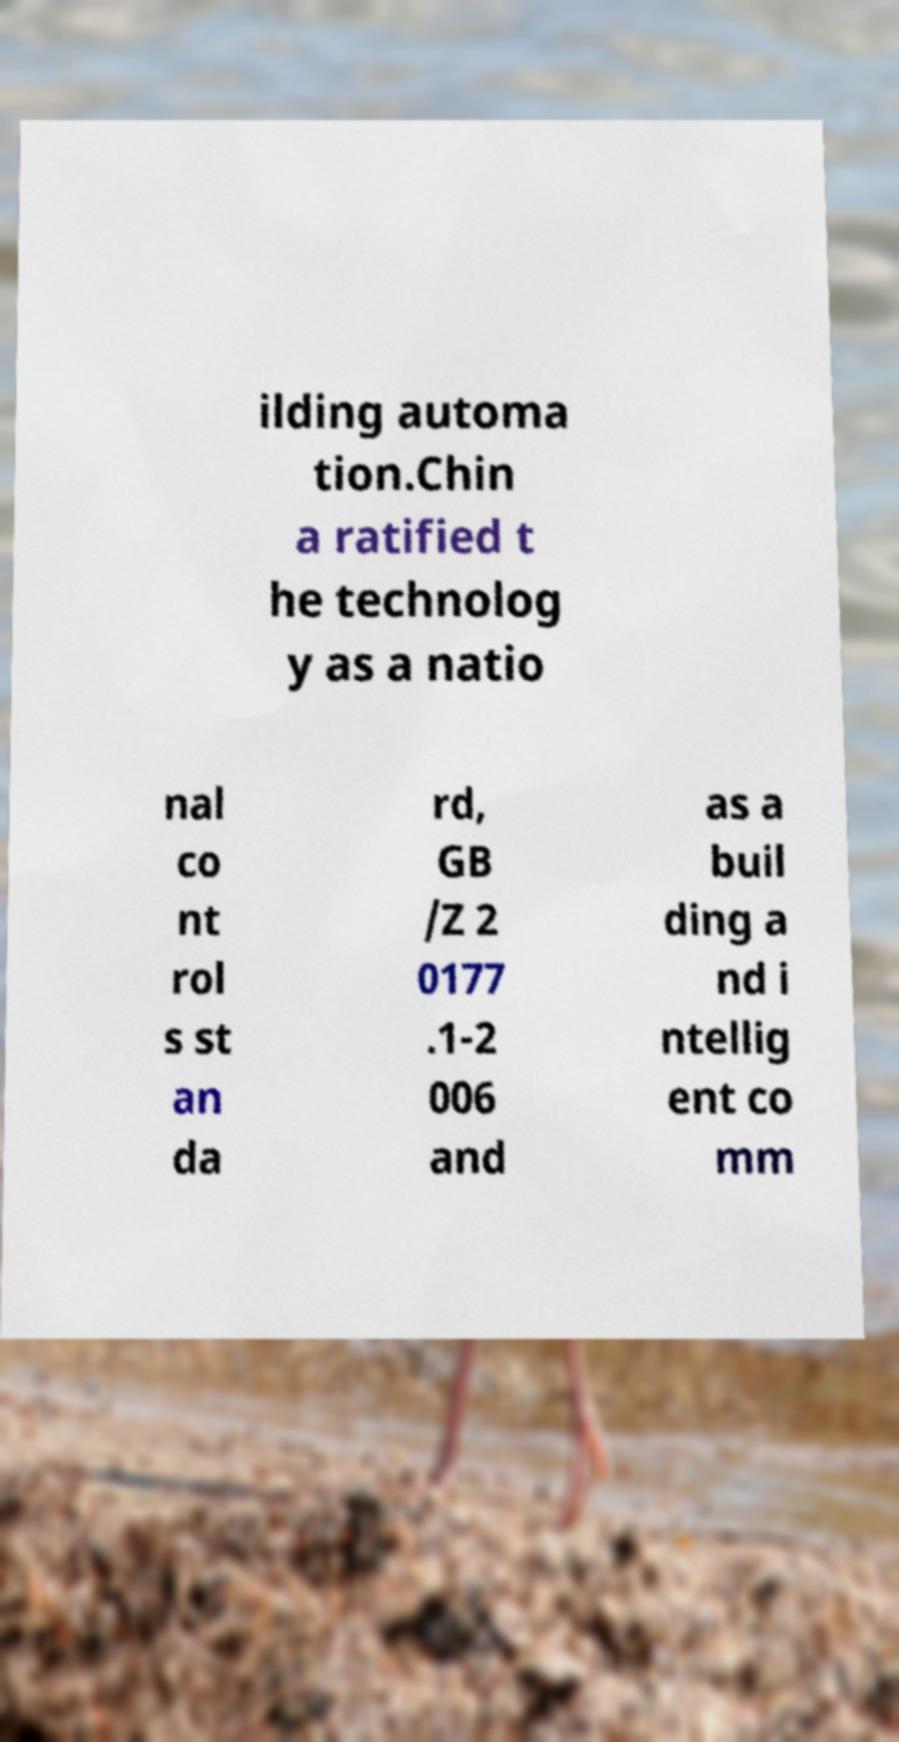Can you accurately transcribe the text from the provided image for me? ilding automa tion.Chin a ratified t he technolog y as a natio nal co nt rol s st an da rd, GB /Z 2 0177 .1-2 006 and as a buil ding a nd i ntellig ent co mm 